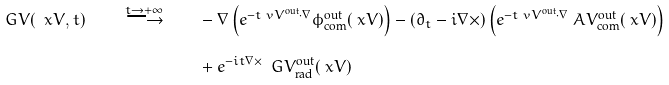<formula> <loc_0><loc_0><loc_500><loc_500>\ G V ( \ x V , t ) \quad \stackrel { t \to + \infty } { \longrightarrow } \quad & - \nabla \left ( e ^ { - t \ v V ^ { \text {out} } \cdot \nabla } \phi _ { \text {com} } ^ { \text {out} } ( \ x V ) \right ) - ( \partial _ { t } - i \nabla \times ) \left ( e ^ { - t \ v V ^ { \text {out} } \cdot \nabla } \ A V _ { \text {com} } ^ { \text {out} } ( \ x V ) \right ) \\ & + e ^ { - i t \nabla \times } \ \ G V ^ { \text {out} } _ { \text {rad} } ( \ x V )</formula> 